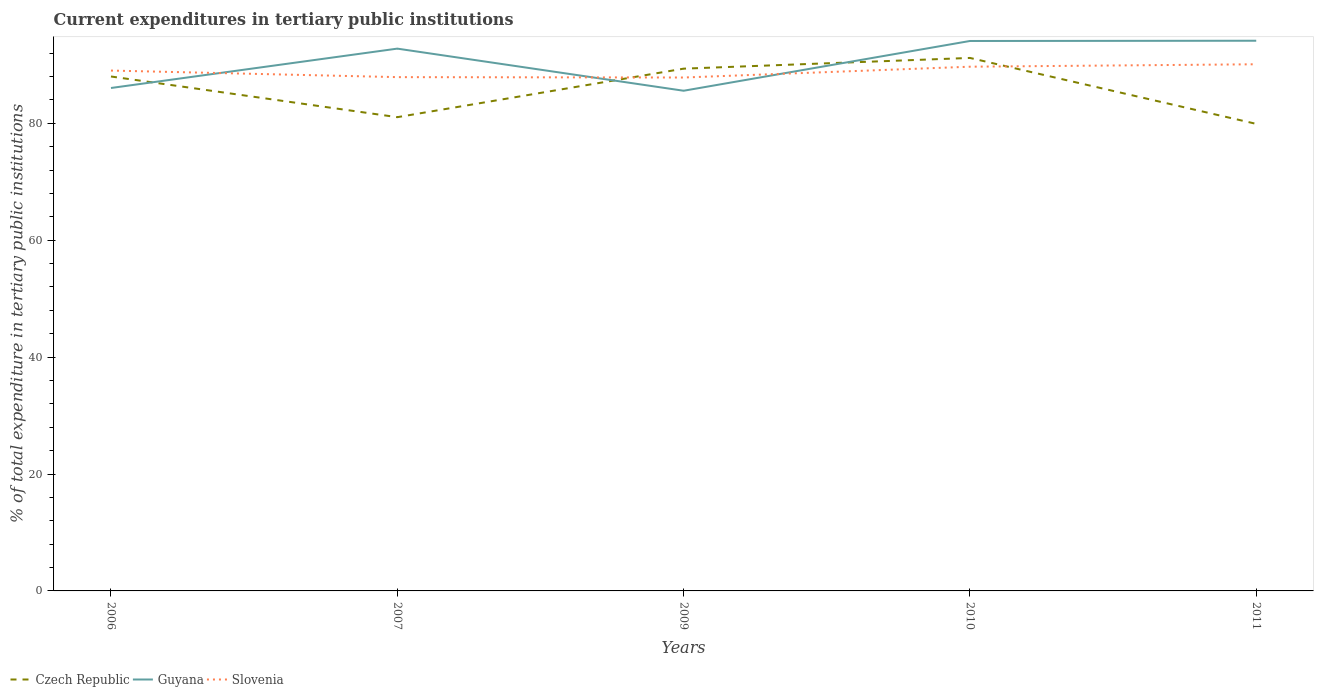How many different coloured lines are there?
Your response must be concise. 3. Is the number of lines equal to the number of legend labels?
Provide a succinct answer. Yes. Across all years, what is the maximum current expenditures in tertiary public institutions in Czech Republic?
Ensure brevity in your answer.  79.9. In which year was the current expenditures in tertiary public institutions in Czech Republic maximum?
Your response must be concise. 2011. What is the total current expenditures in tertiary public institutions in Czech Republic in the graph?
Your answer should be very brief. 1.15. What is the difference between the highest and the second highest current expenditures in tertiary public institutions in Slovenia?
Your response must be concise. 2.27. What is the difference between the highest and the lowest current expenditures in tertiary public institutions in Guyana?
Offer a terse response. 3. Is the current expenditures in tertiary public institutions in Czech Republic strictly greater than the current expenditures in tertiary public institutions in Guyana over the years?
Make the answer very short. No. What is the difference between two consecutive major ticks on the Y-axis?
Offer a very short reply. 20. Does the graph contain any zero values?
Give a very brief answer. No. What is the title of the graph?
Ensure brevity in your answer.  Current expenditures in tertiary public institutions. Does "Latin America(all income levels)" appear as one of the legend labels in the graph?
Your response must be concise. No. What is the label or title of the X-axis?
Provide a succinct answer. Years. What is the label or title of the Y-axis?
Your answer should be compact. % of total expenditure in tertiary public institutions. What is the % of total expenditure in tertiary public institutions of Czech Republic in 2006?
Offer a terse response. 88.01. What is the % of total expenditure in tertiary public institutions in Guyana in 2006?
Ensure brevity in your answer.  86.04. What is the % of total expenditure in tertiary public institutions in Slovenia in 2006?
Your answer should be very brief. 89.02. What is the % of total expenditure in tertiary public institutions in Czech Republic in 2007?
Your answer should be compact. 81.05. What is the % of total expenditure in tertiary public institutions in Guyana in 2007?
Your answer should be compact. 92.78. What is the % of total expenditure in tertiary public institutions in Slovenia in 2007?
Provide a short and direct response. 87.9. What is the % of total expenditure in tertiary public institutions of Czech Republic in 2009?
Your answer should be very brief. 89.35. What is the % of total expenditure in tertiary public institutions of Guyana in 2009?
Your response must be concise. 85.57. What is the % of total expenditure in tertiary public institutions in Slovenia in 2009?
Your answer should be compact. 87.83. What is the % of total expenditure in tertiary public institutions in Czech Republic in 2010?
Your response must be concise. 91.18. What is the % of total expenditure in tertiary public institutions of Guyana in 2010?
Keep it short and to the point. 94.08. What is the % of total expenditure in tertiary public institutions in Slovenia in 2010?
Ensure brevity in your answer.  89.68. What is the % of total expenditure in tertiary public institutions of Czech Republic in 2011?
Ensure brevity in your answer.  79.9. What is the % of total expenditure in tertiary public institutions of Guyana in 2011?
Make the answer very short. 94.13. What is the % of total expenditure in tertiary public institutions of Slovenia in 2011?
Give a very brief answer. 90.1. Across all years, what is the maximum % of total expenditure in tertiary public institutions of Czech Republic?
Give a very brief answer. 91.18. Across all years, what is the maximum % of total expenditure in tertiary public institutions in Guyana?
Offer a very short reply. 94.13. Across all years, what is the maximum % of total expenditure in tertiary public institutions of Slovenia?
Offer a terse response. 90.1. Across all years, what is the minimum % of total expenditure in tertiary public institutions of Czech Republic?
Provide a succinct answer. 79.9. Across all years, what is the minimum % of total expenditure in tertiary public institutions of Guyana?
Your response must be concise. 85.57. Across all years, what is the minimum % of total expenditure in tertiary public institutions in Slovenia?
Ensure brevity in your answer.  87.83. What is the total % of total expenditure in tertiary public institutions of Czech Republic in the graph?
Your answer should be very brief. 429.49. What is the total % of total expenditure in tertiary public institutions of Guyana in the graph?
Provide a short and direct response. 452.59. What is the total % of total expenditure in tertiary public institutions in Slovenia in the graph?
Keep it short and to the point. 444.54. What is the difference between the % of total expenditure in tertiary public institutions in Czech Republic in 2006 and that in 2007?
Offer a very short reply. 6.96. What is the difference between the % of total expenditure in tertiary public institutions of Guyana in 2006 and that in 2007?
Offer a very short reply. -6.73. What is the difference between the % of total expenditure in tertiary public institutions in Slovenia in 2006 and that in 2007?
Offer a terse response. 1.12. What is the difference between the % of total expenditure in tertiary public institutions of Czech Republic in 2006 and that in 2009?
Your answer should be very brief. -1.34. What is the difference between the % of total expenditure in tertiary public institutions of Guyana in 2006 and that in 2009?
Provide a succinct answer. 0.47. What is the difference between the % of total expenditure in tertiary public institutions in Slovenia in 2006 and that in 2009?
Keep it short and to the point. 1.19. What is the difference between the % of total expenditure in tertiary public institutions in Czech Republic in 2006 and that in 2010?
Your response must be concise. -3.18. What is the difference between the % of total expenditure in tertiary public institutions in Guyana in 2006 and that in 2010?
Provide a succinct answer. -8.04. What is the difference between the % of total expenditure in tertiary public institutions in Slovenia in 2006 and that in 2010?
Your response must be concise. -0.66. What is the difference between the % of total expenditure in tertiary public institutions in Czech Republic in 2006 and that in 2011?
Provide a succinct answer. 8.11. What is the difference between the % of total expenditure in tertiary public institutions of Guyana in 2006 and that in 2011?
Your answer should be compact. -8.09. What is the difference between the % of total expenditure in tertiary public institutions in Slovenia in 2006 and that in 2011?
Your answer should be compact. -1.08. What is the difference between the % of total expenditure in tertiary public institutions in Czech Republic in 2007 and that in 2009?
Keep it short and to the point. -8.3. What is the difference between the % of total expenditure in tertiary public institutions in Guyana in 2007 and that in 2009?
Provide a short and direct response. 7.21. What is the difference between the % of total expenditure in tertiary public institutions of Slovenia in 2007 and that in 2009?
Keep it short and to the point. 0.07. What is the difference between the % of total expenditure in tertiary public institutions in Czech Republic in 2007 and that in 2010?
Offer a very short reply. -10.14. What is the difference between the % of total expenditure in tertiary public institutions of Guyana in 2007 and that in 2010?
Make the answer very short. -1.31. What is the difference between the % of total expenditure in tertiary public institutions of Slovenia in 2007 and that in 2010?
Offer a terse response. -1.78. What is the difference between the % of total expenditure in tertiary public institutions of Czech Republic in 2007 and that in 2011?
Your answer should be compact. 1.15. What is the difference between the % of total expenditure in tertiary public institutions in Guyana in 2007 and that in 2011?
Your response must be concise. -1.35. What is the difference between the % of total expenditure in tertiary public institutions in Slovenia in 2007 and that in 2011?
Offer a terse response. -2.2. What is the difference between the % of total expenditure in tertiary public institutions of Czech Republic in 2009 and that in 2010?
Offer a very short reply. -1.84. What is the difference between the % of total expenditure in tertiary public institutions of Guyana in 2009 and that in 2010?
Provide a short and direct response. -8.51. What is the difference between the % of total expenditure in tertiary public institutions of Slovenia in 2009 and that in 2010?
Your answer should be compact. -1.85. What is the difference between the % of total expenditure in tertiary public institutions of Czech Republic in 2009 and that in 2011?
Your answer should be compact. 9.45. What is the difference between the % of total expenditure in tertiary public institutions in Guyana in 2009 and that in 2011?
Your answer should be compact. -8.56. What is the difference between the % of total expenditure in tertiary public institutions in Slovenia in 2009 and that in 2011?
Your answer should be very brief. -2.27. What is the difference between the % of total expenditure in tertiary public institutions of Czech Republic in 2010 and that in 2011?
Your answer should be very brief. 11.28. What is the difference between the % of total expenditure in tertiary public institutions of Guyana in 2010 and that in 2011?
Offer a very short reply. -0.04. What is the difference between the % of total expenditure in tertiary public institutions of Slovenia in 2010 and that in 2011?
Your answer should be very brief. -0.42. What is the difference between the % of total expenditure in tertiary public institutions of Czech Republic in 2006 and the % of total expenditure in tertiary public institutions of Guyana in 2007?
Your answer should be very brief. -4.77. What is the difference between the % of total expenditure in tertiary public institutions in Czech Republic in 2006 and the % of total expenditure in tertiary public institutions in Slovenia in 2007?
Your answer should be very brief. 0.11. What is the difference between the % of total expenditure in tertiary public institutions of Guyana in 2006 and the % of total expenditure in tertiary public institutions of Slovenia in 2007?
Your answer should be very brief. -1.86. What is the difference between the % of total expenditure in tertiary public institutions of Czech Republic in 2006 and the % of total expenditure in tertiary public institutions of Guyana in 2009?
Offer a very short reply. 2.44. What is the difference between the % of total expenditure in tertiary public institutions in Czech Republic in 2006 and the % of total expenditure in tertiary public institutions in Slovenia in 2009?
Your answer should be very brief. 0.18. What is the difference between the % of total expenditure in tertiary public institutions of Guyana in 2006 and the % of total expenditure in tertiary public institutions of Slovenia in 2009?
Provide a succinct answer. -1.79. What is the difference between the % of total expenditure in tertiary public institutions of Czech Republic in 2006 and the % of total expenditure in tertiary public institutions of Guyana in 2010?
Your answer should be compact. -6.07. What is the difference between the % of total expenditure in tertiary public institutions of Czech Republic in 2006 and the % of total expenditure in tertiary public institutions of Slovenia in 2010?
Keep it short and to the point. -1.68. What is the difference between the % of total expenditure in tertiary public institutions in Guyana in 2006 and the % of total expenditure in tertiary public institutions in Slovenia in 2010?
Ensure brevity in your answer.  -3.64. What is the difference between the % of total expenditure in tertiary public institutions of Czech Republic in 2006 and the % of total expenditure in tertiary public institutions of Guyana in 2011?
Your answer should be compact. -6.12. What is the difference between the % of total expenditure in tertiary public institutions of Czech Republic in 2006 and the % of total expenditure in tertiary public institutions of Slovenia in 2011?
Offer a very short reply. -2.09. What is the difference between the % of total expenditure in tertiary public institutions of Guyana in 2006 and the % of total expenditure in tertiary public institutions of Slovenia in 2011?
Offer a terse response. -4.06. What is the difference between the % of total expenditure in tertiary public institutions in Czech Republic in 2007 and the % of total expenditure in tertiary public institutions in Guyana in 2009?
Give a very brief answer. -4.52. What is the difference between the % of total expenditure in tertiary public institutions of Czech Republic in 2007 and the % of total expenditure in tertiary public institutions of Slovenia in 2009?
Your response must be concise. -6.78. What is the difference between the % of total expenditure in tertiary public institutions in Guyana in 2007 and the % of total expenditure in tertiary public institutions in Slovenia in 2009?
Ensure brevity in your answer.  4.94. What is the difference between the % of total expenditure in tertiary public institutions of Czech Republic in 2007 and the % of total expenditure in tertiary public institutions of Guyana in 2010?
Your response must be concise. -13.03. What is the difference between the % of total expenditure in tertiary public institutions in Czech Republic in 2007 and the % of total expenditure in tertiary public institutions in Slovenia in 2010?
Offer a very short reply. -8.64. What is the difference between the % of total expenditure in tertiary public institutions in Guyana in 2007 and the % of total expenditure in tertiary public institutions in Slovenia in 2010?
Your answer should be very brief. 3.09. What is the difference between the % of total expenditure in tertiary public institutions of Czech Republic in 2007 and the % of total expenditure in tertiary public institutions of Guyana in 2011?
Keep it short and to the point. -13.08. What is the difference between the % of total expenditure in tertiary public institutions of Czech Republic in 2007 and the % of total expenditure in tertiary public institutions of Slovenia in 2011?
Your answer should be very brief. -9.05. What is the difference between the % of total expenditure in tertiary public institutions of Guyana in 2007 and the % of total expenditure in tertiary public institutions of Slovenia in 2011?
Provide a succinct answer. 2.68. What is the difference between the % of total expenditure in tertiary public institutions of Czech Republic in 2009 and the % of total expenditure in tertiary public institutions of Guyana in 2010?
Keep it short and to the point. -4.73. What is the difference between the % of total expenditure in tertiary public institutions in Czech Republic in 2009 and the % of total expenditure in tertiary public institutions in Slovenia in 2010?
Your response must be concise. -0.34. What is the difference between the % of total expenditure in tertiary public institutions of Guyana in 2009 and the % of total expenditure in tertiary public institutions of Slovenia in 2010?
Your answer should be very brief. -4.11. What is the difference between the % of total expenditure in tertiary public institutions in Czech Republic in 2009 and the % of total expenditure in tertiary public institutions in Guyana in 2011?
Ensure brevity in your answer.  -4.78. What is the difference between the % of total expenditure in tertiary public institutions in Czech Republic in 2009 and the % of total expenditure in tertiary public institutions in Slovenia in 2011?
Offer a terse response. -0.75. What is the difference between the % of total expenditure in tertiary public institutions of Guyana in 2009 and the % of total expenditure in tertiary public institutions of Slovenia in 2011?
Provide a succinct answer. -4.53. What is the difference between the % of total expenditure in tertiary public institutions of Czech Republic in 2010 and the % of total expenditure in tertiary public institutions of Guyana in 2011?
Keep it short and to the point. -2.94. What is the difference between the % of total expenditure in tertiary public institutions of Czech Republic in 2010 and the % of total expenditure in tertiary public institutions of Slovenia in 2011?
Give a very brief answer. 1.08. What is the difference between the % of total expenditure in tertiary public institutions of Guyana in 2010 and the % of total expenditure in tertiary public institutions of Slovenia in 2011?
Make the answer very short. 3.98. What is the average % of total expenditure in tertiary public institutions of Czech Republic per year?
Your answer should be compact. 85.9. What is the average % of total expenditure in tertiary public institutions of Guyana per year?
Keep it short and to the point. 90.52. What is the average % of total expenditure in tertiary public institutions in Slovenia per year?
Give a very brief answer. 88.91. In the year 2006, what is the difference between the % of total expenditure in tertiary public institutions of Czech Republic and % of total expenditure in tertiary public institutions of Guyana?
Your response must be concise. 1.97. In the year 2006, what is the difference between the % of total expenditure in tertiary public institutions in Czech Republic and % of total expenditure in tertiary public institutions in Slovenia?
Your response must be concise. -1.01. In the year 2006, what is the difference between the % of total expenditure in tertiary public institutions of Guyana and % of total expenditure in tertiary public institutions of Slovenia?
Your response must be concise. -2.98. In the year 2007, what is the difference between the % of total expenditure in tertiary public institutions in Czech Republic and % of total expenditure in tertiary public institutions in Guyana?
Provide a succinct answer. -11.73. In the year 2007, what is the difference between the % of total expenditure in tertiary public institutions of Czech Republic and % of total expenditure in tertiary public institutions of Slovenia?
Your answer should be very brief. -6.85. In the year 2007, what is the difference between the % of total expenditure in tertiary public institutions of Guyana and % of total expenditure in tertiary public institutions of Slovenia?
Keep it short and to the point. 4.88. In the year 2009, what is the difference between the % of total expenditure in tertiary public institutions of Czech Republic and % of total expenditure in tertiary public institutions of Guyana?
Make the answer very short. 3.78. In the year 2009, what is the difference between the % of total expenditure in tertiary public institutions in Czech Republic and % of total expenditure in tertiary public institutions in Slovenia?
Offer a very short reply. 1.52. In the year 2009, what is the difference between the % of total expenditure in tertiary public institutions of Guyana and % of total expenditure in tertiary public institutions of Slovenia?
Your response must be concise. -2.26. In the year 2010, what is the difference between the % of total expenditure in tertiary public institutions of Czech Republic and % of total expenditure in tertiary public institutions of Guyana?
Your answer should be very brief. -2.9. In the year 2010, what is the difference between the % of total expenditure in tertiary public institutions in Czech Republic and % of total expenditure in tertiary public institutions in Slovenia?
Offer a terse response. 1.5. In the year 2010, what is the difference between the % of total expenditure in tertiary public institutions in Guyana and % of total expenditure in tertiary public institutions in Slovenia?
Offer a terse response. 4.4. In the year 2011, what is the difference between the % of total expenditure in tertiary public institutions in Czech Republic and % of total expenditure in tertiary public institutions in Guyana?
Offer a very short reply. -14.22. In the year 2011, what is the difference between the % of total expenditure in tertiary public institutions in Czech Republic and % of total expenditure in tertiary public institutions in Slovenia?
Provide a short and direct response. -10.2. In the year 2011, what is the difference between the % of total expenditure in tertiary public institutions of Guyana and % of total expenditure in tertiary public institutions of Slovenia?
Make the answer very short. 4.03. What is the ratio of the % of total expenditure in tertiary public institutions of Czech Republic in 2006 to that in 2007?
Provide a succinct answer. 1.09. What is the ratio of the % of total expenditure in tertiary public institutions of Guyana in 2006 to that in 2007?
Give a very brief answer. 0.93. What is the ratio of the % of total expenditure in tertiary public institutions of Slovenia in 2006 to that in 2007?
Ensure brevity in your answer.  1.01. What is the ratio of the % of total expenditure in tertiary public institutions in Slovenia in 2006 to that in 2009?
Keep it short and to the point. 1.01. What is the ratio of the % of total expenditure in tertiary public institutions in Czech Republic in 2006 to that in 2010?
Make the answer very short. 0.97. What is the ratio of the % of total expenditure in tertiary public institutions of Guyana in 2006 to that in 2010?
Provide a succinct answer. 0.91. What is the ratio of the % of total expenditure in tertiary public institutions of Czech Republic in 2006 to that in 2011?
Keep it short and to the point. 1.1. What is the ratio of the % of total expenditure in tertiary public institutions in Guyana in 2006 to that in 2011?
Provide a short and direct response. 0.91. What is the ratio of the % of total expenditure in tertiary public institutions in Czech Republic in 2007 to that in 2009?
Give a very brief answer. 0.91. What is the ratio of the % of total expenditure in tertiary public institutions of Guyana in 2007 to that in 2009?
Give a very brief answer. 1.08. What is the ratio of the % of total expenditure in tertiary public institutions of Czech Republic in 2007 to that in 2010?
Provide a short and direct response. 0.89. What is the ratio of the % of total expenditure in tertiary public institutions in Guyana in 2007 to that in 2010?
Your answer should be compact. 0.99. What is the ratio of the % of total expenditure in tertiary public institutions in Slovenia in 2007 to that in 2010?
Provide a short and direct response. 0.98. What is the ratio of the % of total expenditure in tertiary public institutions of Czech Republic in 2007 to that in 2011?
Make the answer very short. 1.01. What is the ratio of the % of total expenditure in tertiary public institutions in Guyana in 2007 to that in 2011?
Offer a very short reply. 0.99. What is the ratio of the % of total expenditure in tertiary public institutions in Slovenia in 2007 to that in 2011?
Keep it short and to the point. 0.98. What is the ratio of the % of total expenditure in tertiary public institutions in Czech Republic in 2009 to that in 2010?
Your response must be concise. 0.98. What is the ratio of the % of total expenditure in tertiary public institutions in Guyana in 2009 to that in 2010?
Your response must be concise. 0.91. What is the ratio of the % of total expenditure in tertiary public institutions of Slovenia in 2009 to that in 2010?
Your answer should be very brief. 0.98. What is the ratio of the % of total expenditure in tertiary public institutions in Czech Republic in 2009 to that in 2011?
Give a very brief answer. 1.12. What is the ratio of the % of total expenditure in tertiary public institutions of Slovenia in 2009 to that in 2011?
Make the answer very short. 0.97. What is the ratio of the % of total expenditure in tertiary public institutions of Czech Republic in 2010 to that in 2011?
Your answer should be very brief. 1.14. What is the ratio of the % of total expenditure in tertiary public institutions of Guyana in 2010 to that in 2011?
Give a very brief answer. 1. What is the ratio of the % of total expenditure in tertiary public institutions of Slovenia in 2010 to that in 2011?
Give a very brief answer. 1. What is the difference between the highest and the second highest % of total expenditure in tertiary public institutions in Czech Republic?
Your answer should be very brief. 1.84. What is the difference between the highest and the second highest % of total expenditure in tertiary public institutions in Guyana?
Offer a terse response. 0.04. What is the difference between the highest and the second highest % of total expenditure in tertiary public institutions of Slovenia?
Offer a very short reply. 0.42. What is the difference between the highest and the lowest % of total expenditure in tertiary public institutions of Czech Republic?
Provide a short and direct response. 11.28. What is the difference between the highest and the lowest % of total expenditure in tertiary public institutions in Guyana?
Ensure brevity in your answer.  8.56. What is the difference between the highest and the lowest % of total expenditure in tertiary public institutions of Slovenia?
Give a very brief answer. 2.27. 